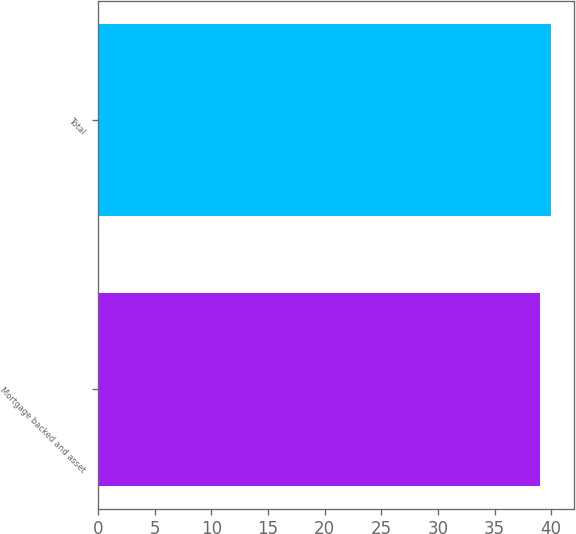Convert chart to OTSL. <chart><loc_0><loc_0><loc_500><loc_500><bar_chart><fcel>Mortgage backed and asset<fcel>Total<nl><fcel>39<fcel>40<nl></chart> 